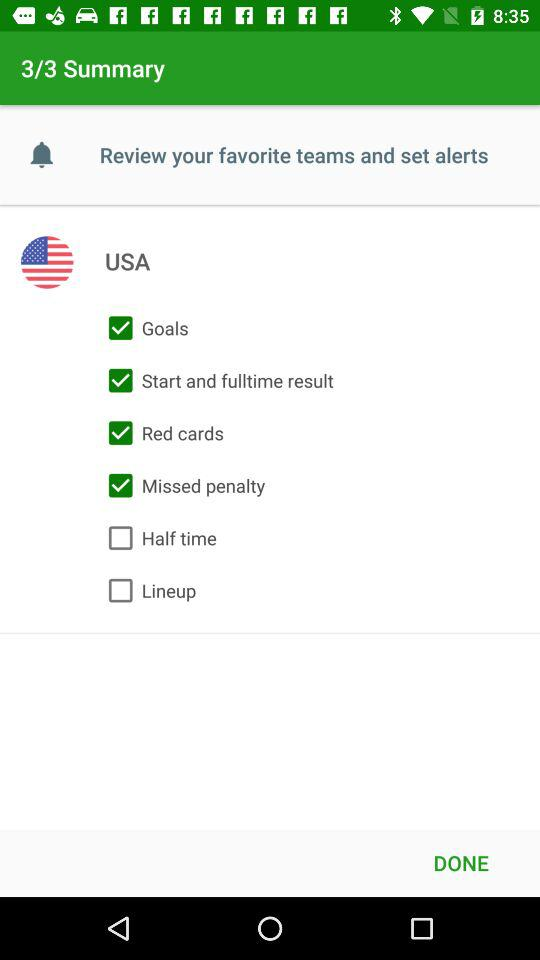What is the status of "Goals"? The status of "Goals" is "on". 